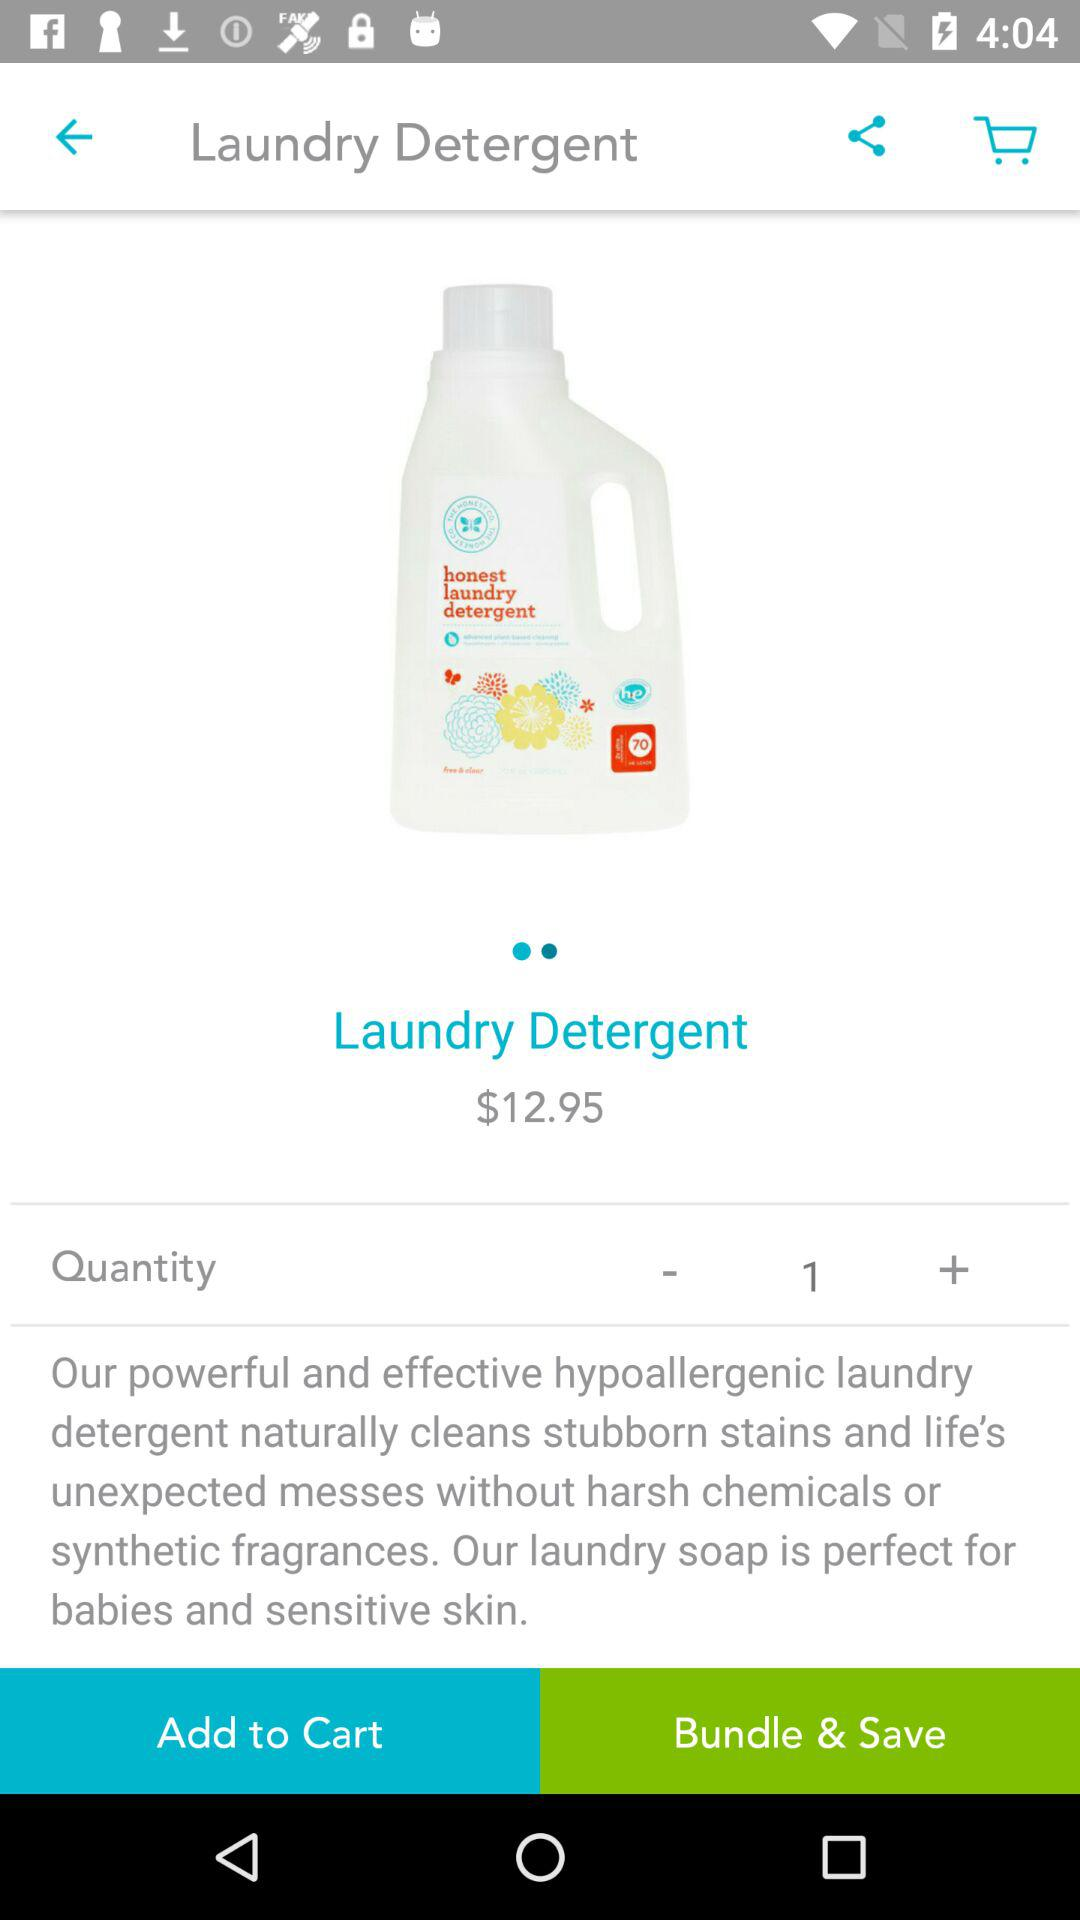What is the currency of price? The currency of price is dollars. 